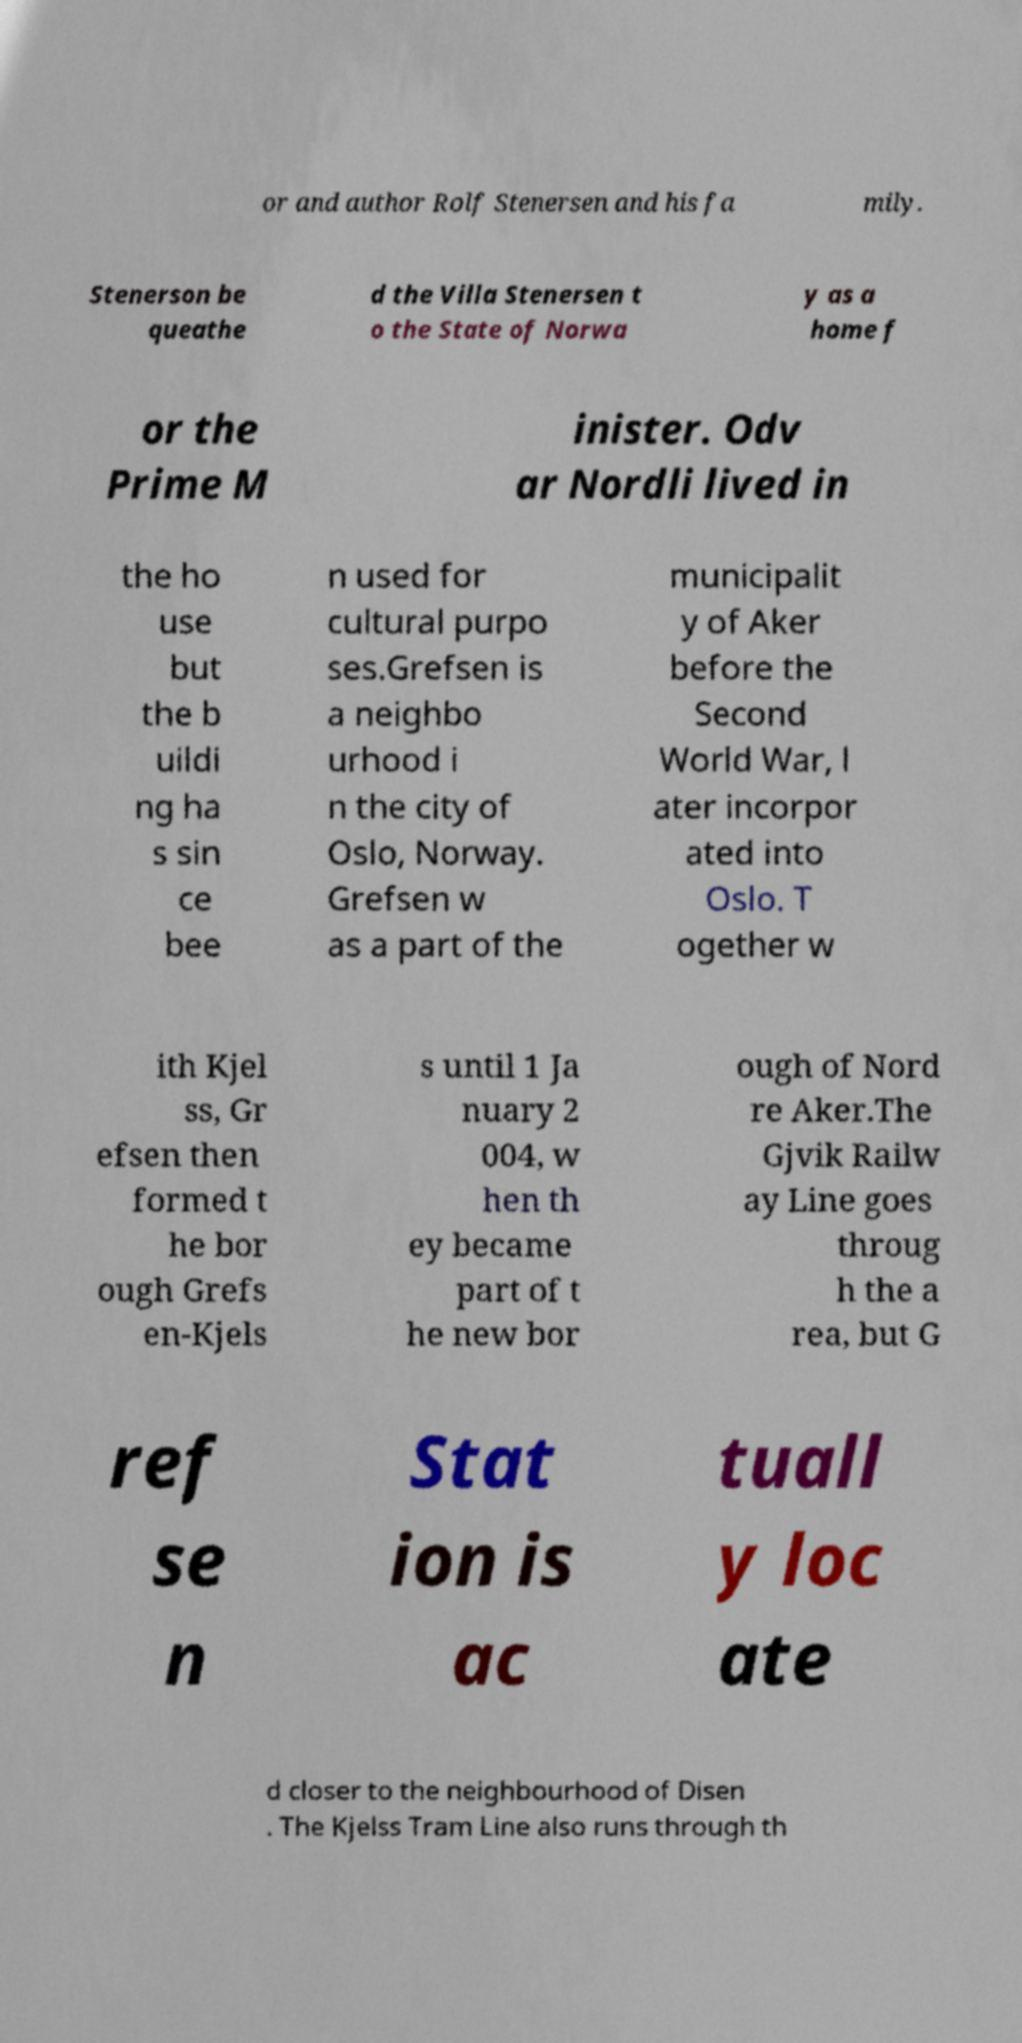Can you read and provide the text displayed in the image?This photo seems to have some interesting text. Can you extract and type it out for me? or and author Rolf Stenersen and his fa mily. Stenerson be queathe d the Villa Stenersen t o the State of Norwa y as a home f or the Prime M inister. Odv ar Nordli lived in the ho use but the b uildi ng ha s sin ce bee n used for cultural purpo ses.Grefsen is a neighbo urhood i n the city of Oslo, Norway. Grefsen w as a part of the municipalit y of Aker before the Second World War, l ater incorpor ated into Oslo. T ogether w ith Kjel ss, Gr efsen then formed t he bor ough Grefs en-Kjels s until 1 Ja nuary 2 004, w hen th ey became part of t he new bor ough of Nord re Aker.The Gjvik Railw ay Line goes throug h the a rea, but G ref se n Stat ion is ac tuall y loc ate d closer to the neighbourhood of Disen . The Kjelss Tram Line also runs through th 